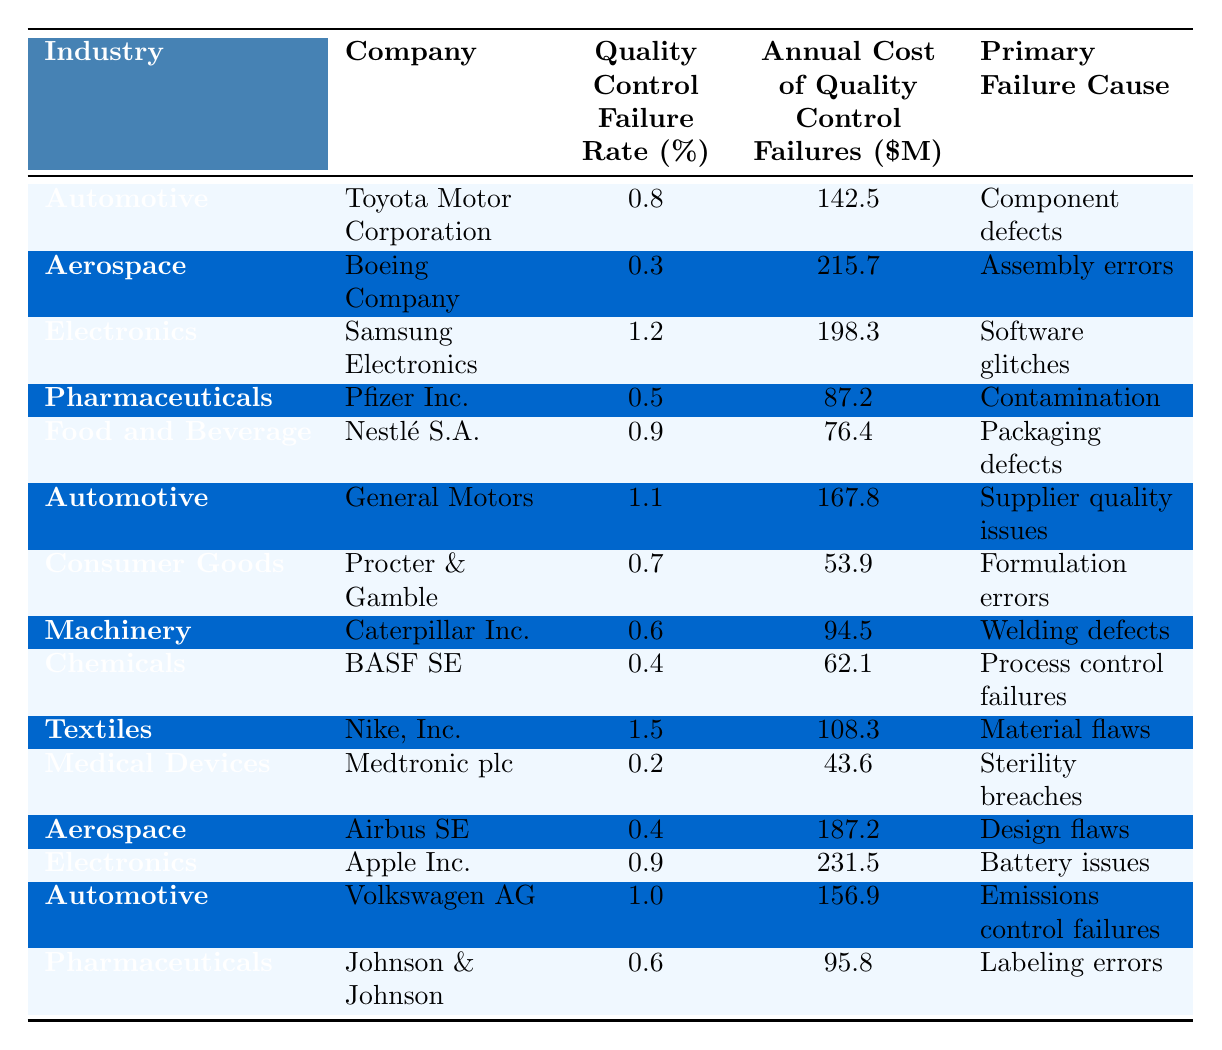What is the Quality Control Failure Rate for Boeing Company? The table lists details for the Boeing Company under the Aerospace industry, showing a Quality Control Failure Rate of 0.3%.
Answer: 0.3% Which industry has the highest Annual Cost of Quality Control Failures? By examining the table, we find that the Aerospace industry, represented by Boeing Company, has the highest Annual Cost of Quality Control Failures at $215.7 million.
Answer: $215.7 million What is the average Quality Control Failure Rate for the Automotive industry? The Automotive industry data includes Toyota (0.8%), General Motors (1.1%), and Volkswagen (1.0%). Calculating the average: (0.8 + 1.1 + 1.0) / 3 = 1.0%.
Answer: 1.0% Is the primary failure cause for Pfizer Inc. related to contamination? Looking at the entry for Pfizer Inc. under Pharmaceuticals, the primary failure cause is indeed listed as contamination.
Answer: Yes What is the total Annual Cost of Quality Control Failures for the Electronics industry? The Electronics industry shows two companies: Samsung ($198.3 million) and Apple ($231.5 million). Adding them together gives $198.3 + $231.5 = $429.8 million.
Answer: $429.8 million Which company in the Textiles industry has a failure rate of 1.5%? The table indicates that Nike, Inc. in the Textiles industry has a Quality Control Failure Rate of 1.5%.
Answer: Nike, Inc How many industries have a Quality Control Failure Rate greater than 1%? The table shows three companies with rates over 1%: Samsung (1.2%), General Motors (1.1%), and Nike (1.5%). Therefore, there are a total of three industries.
Answer: 3 What percentage of companies listed have a primary failure cause related to defects or errors? Analyzing the table, we see companies listing component defects, assembly errors, software glitches, contamination, packaging defects, supplier quality issues, formulation errors, welding defects, process control failures, material flaws, sterility breaches, design flaws, battery issues, emissions control failures, and labeling errors. Of the 14 companies, 12 have causes related to defects or errors, giving a percentage of (12/14)*100 = 85.71%.
Answer: 85.71% Which company demonstrates the lowest Annual Cost of Quality Control Failures? Reviewing the entries, Medtronic plc in the Medical Devices industry has the lowest Annual Cost of Quality Control Failures at $43.6 million.
Answer: $43.6 million Is it true that all companies in the Aerospace industry have a failure rate of 0.4% or less? There are two companies in the Aerospace industry (Boeing at 0.3% and Airbus at 0.4%), which supports the statement that both have a failure rate of 0.4% or less.
Answer: Yes 